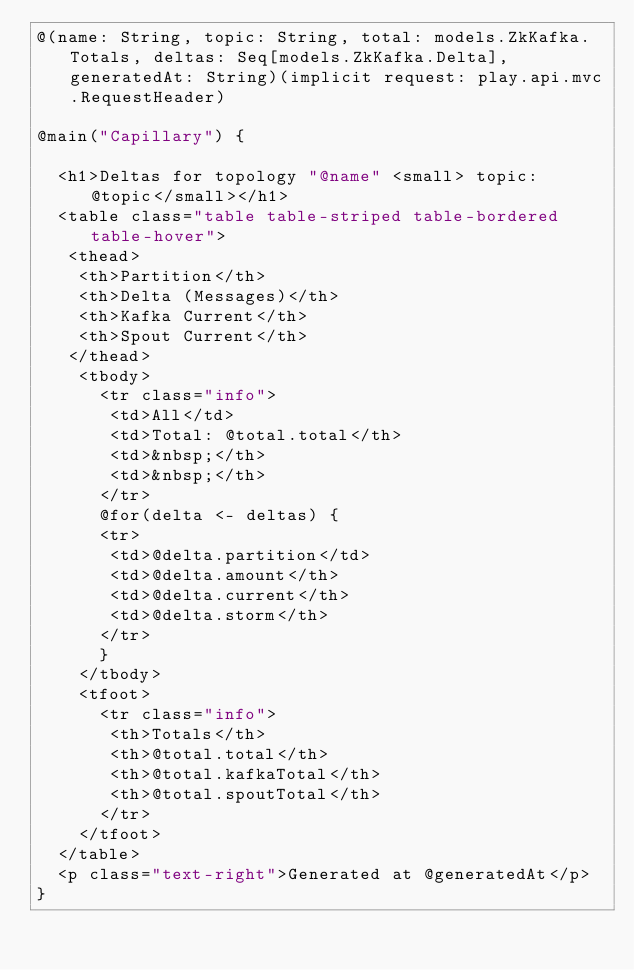<code> <loc_0><loc_0><loc_500><loc_500><_HTML_>@(name: String, topic: String, total: models.ZkKafka.Totals, deltas: Seq[models.ZkKafka.Delta], generatedAt: String)(implicit request: play.api.mvc.RequestHeader)

@main("Capillary") {

  <h1>Deltas for topology "@name" <small> topic: @topic</small></h1>
  <table class="table table-striped table-bordered table-hover">
   <thead>
    <th>Partition</th>
    <th>Delta (Messages)</th>
    <th>Kafka Current</th>
    <th>Spout Current</th>
   </thead>
    <tbody>
      <tr class="info">
       <td>All</td>
       <td>Total: @total.total</th>
       <td>&nbsp;</th>
       <td>&nbsp;</th>
      </tr>
      @for(delta <- deltas) {
      <tr>
       <td>@delta.partition</td>
       <td>@delta.amount</th>
       <td>@delta.current</th>
       <td>@delta.storm</th>
      </tr>
      }
    </tbody>
    <tfoot>
      <tr class="info">
       <th>Totals</th>
       <th>@total.total</th>
       <th>@total.kafkaTotal</th>
       <th>@total.spoutTotal</th>
      </tr>
    </tfoot>
  </table>
  <p class="text-right">Generated at @generatedAt</p>
}
</code> 